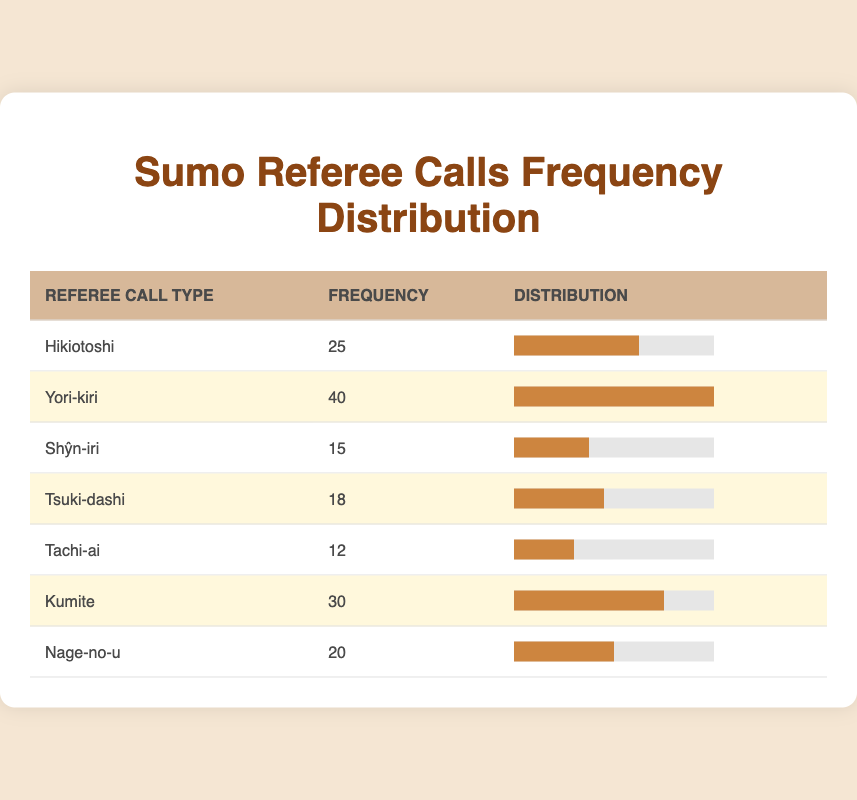What is the frequency of Yori-kiri calls? The table indicates that the frequency of Yori-kiri calls is listed directly under its corresponding row, which shows a frequency of 40.
Answer: 40 Which referee call type has the lowest frequency? Looking at the frequency column, the lowest value is in the row for Shŷn-iri with a frequency of 15.
Answer: Shŷn-iri What is the total frequency of all referee calls? To find the total frequency, sum up all the frequencies: 25 + 40 + 15 + 18 + 12 + 30 + 20 = 170.
Answer: 170 Is the frequency of Kumite greater than that of Nage-no-u? Comparing the frequencies, Kumite has a frequency of 30 while Nage-no-u has 20. Therefore, since 30 is greater than 20, the statement is true.
Answer: Yes What is the average frequency of referee calls? To calculate the average frequency, sum all the frequencies (170) and divide by the number of call types (7): 170 / 7 = approximately 24.29.
Answer: 24.29 Which referee call type accounts for more than 25% of all calls? To find this, calculate 25% of the total frequency (170), which is 42.5. Then check each frequency: Yori-kiri (40) and Kumite (30) are below this threshold, but Hikiotoshi (25), Tsuki-dashi (18), Tachi-ai (12), Shŷn-iri (15), and Nage-no-u (20) also do not meet it. None exceeds 25%.
Answer: None If we combine the frequencies of Tsuki-dashi and Tachi-ai, what is the result? The frequency of Tsuki-dashi is 18, and Tachi-ai is 12. Adding these together gives 18 + 12 = 30.
Answer: 30 How many referee call types have a frequency less than 20? From the table, the types with frequencies lower than 20 are Shŷn-iri (15), Tsuki-dashi (18), and Tachi-ai (12), which make a total of three.
Answer: 3 Which pair of call types has a frequency difference of more than 10? Comparing pairs, Yori-kiri (40) and Shŷn-iri (15) have a difference of 25; Kumite (30) and Tachi-ai (12) have a difference of 18; all other pairs do not exceed 10. Thus, both pairs mentioned have differences greater than 10.
Answer: Two pairs: Yori-kiri & Shŷn-iri, Kumite & Tachi-ai 